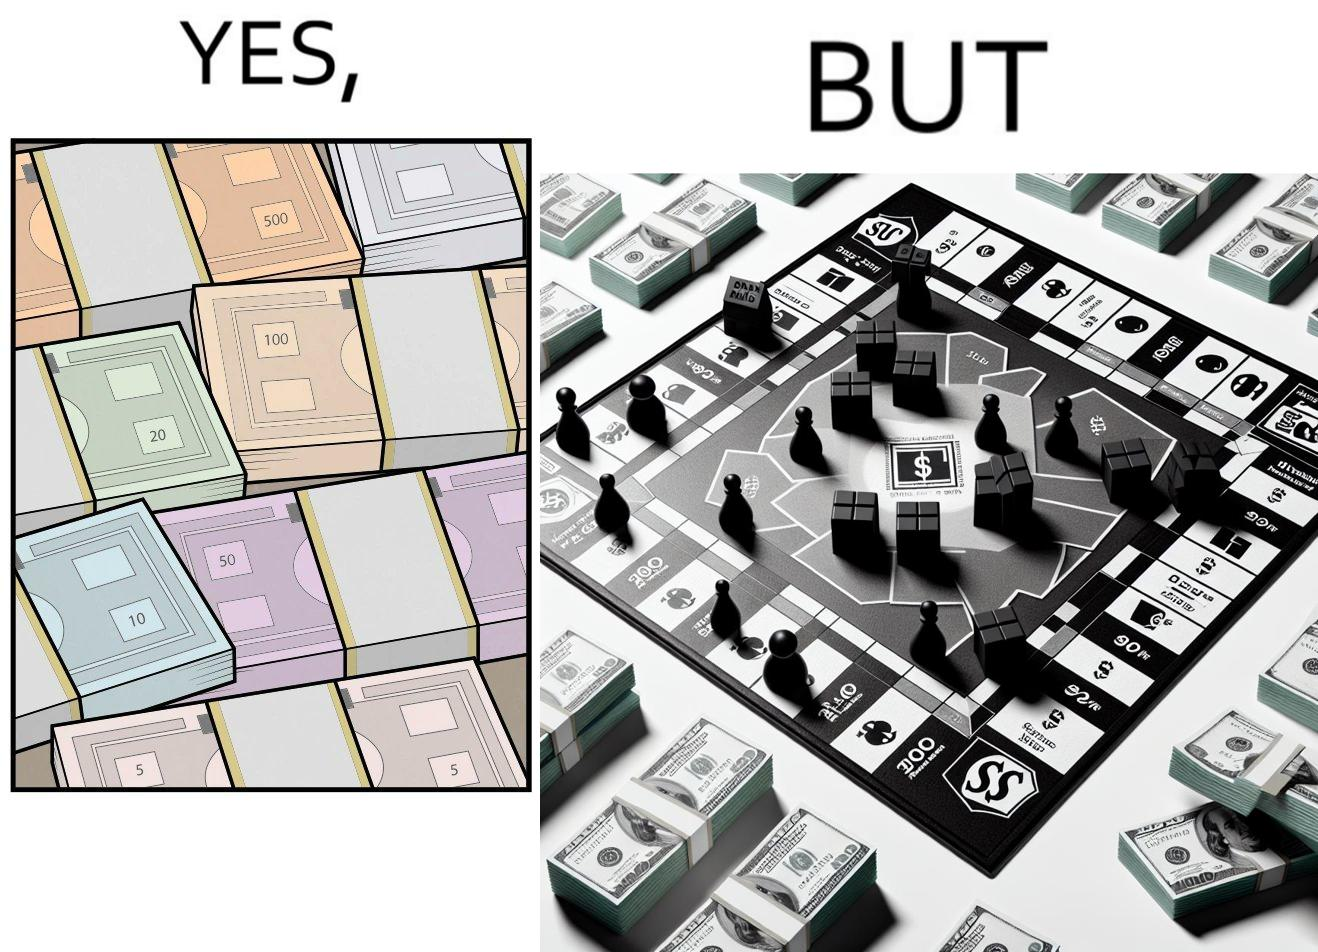Provide a description of this image. The image is ironic, because there are many different color currency notes' bundles but they are just as a currency in the game of monopoly and they have no real value 